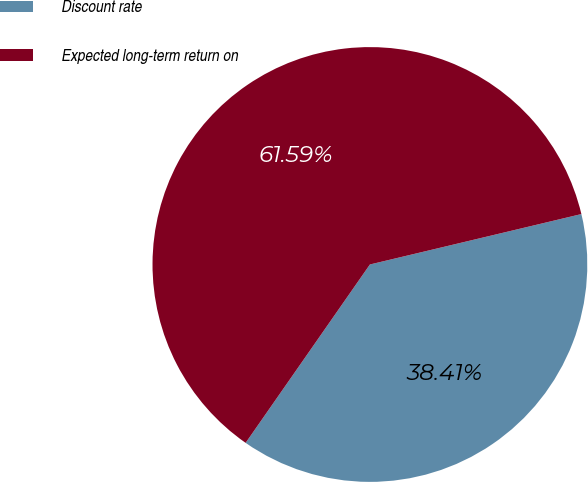<chart> <loc_0><loc_0><loc_500><loc_500><pie_chart><fcel>Discount rate<fcel>Expected long-term return on<nl><fcel>38.41%<fcel>61.59%<nl></chart> 